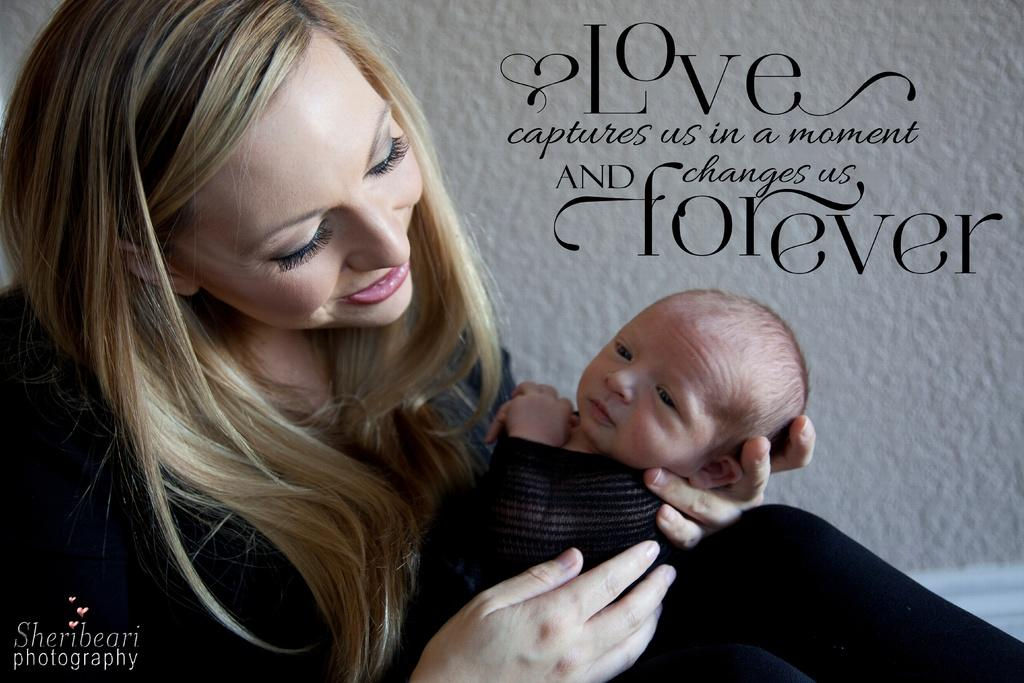What is the woman in the image doing? The woman is sitting and holding a child in the image. What else can be seen in the image besides the woman and the child? There is text visible in the image. What is in the background of the image? There is a wall in the background of the image. How far away is the committee from the woman in the image? There is no committee present in the image, so it is not possible to determine the distance between them. 